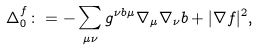<formula> <loc_0><loc_0><loc_500><loc_500>\Delta ^ { f } _ { 0 } \colon = - \sum _ { \mu \nu } g ^ { \nu b \mu } \nabla _ { \mu } \nabla _ { \nu } b + | \nabla f | ^ { 2 } ,</formula> 